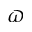<formula> <loc_0><loc_0><loc_500><loc_500>\varpi</formula> 